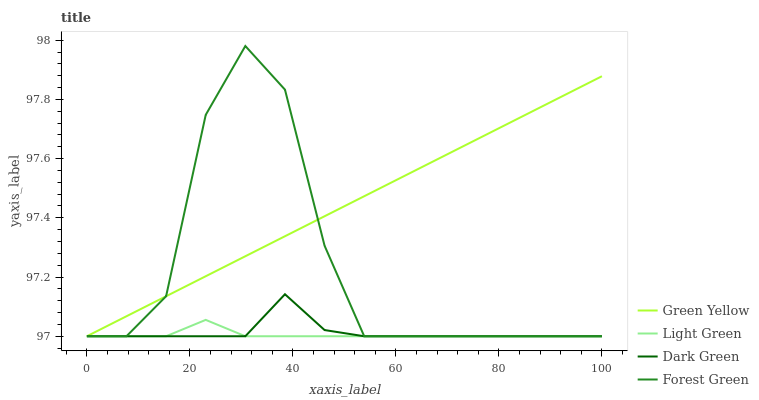Does Light Green have the minimum area under the curve?
Answer yes or no. Yes. Does Green Yellow have the maximum area under the curve?
Answer yes or no. Yes. Does Green Yellow have the minimum area under the curve?
Answer yes or no. No. Does Light Green have the maximum area under the curve?
Answer yes or no. No. Is Green Yellow the smoothest?
Answer yes or no. Yes. Is Forest Green the roughest?
Answer yes or no. Yes. Is Light Green the smoothest?
Answer yes or no. No. Is Light Green the roughest?
Answer yes or no. No. Does Forest Green have the lowest value?
Answer yes or no. Yes. Does Forest Green have the highest value?
Answer yes or no. Yes. Does Green Yellow have the highest value?
Answer yes or no. No. Does Forest Green intersect Green Yellow?
Answer yes or no. Yes. Is Forest Green less than Green Yellow?
Answer yes or no. No. Is Forest Green greater than Green Yellow?
Answer yes or no. No. 